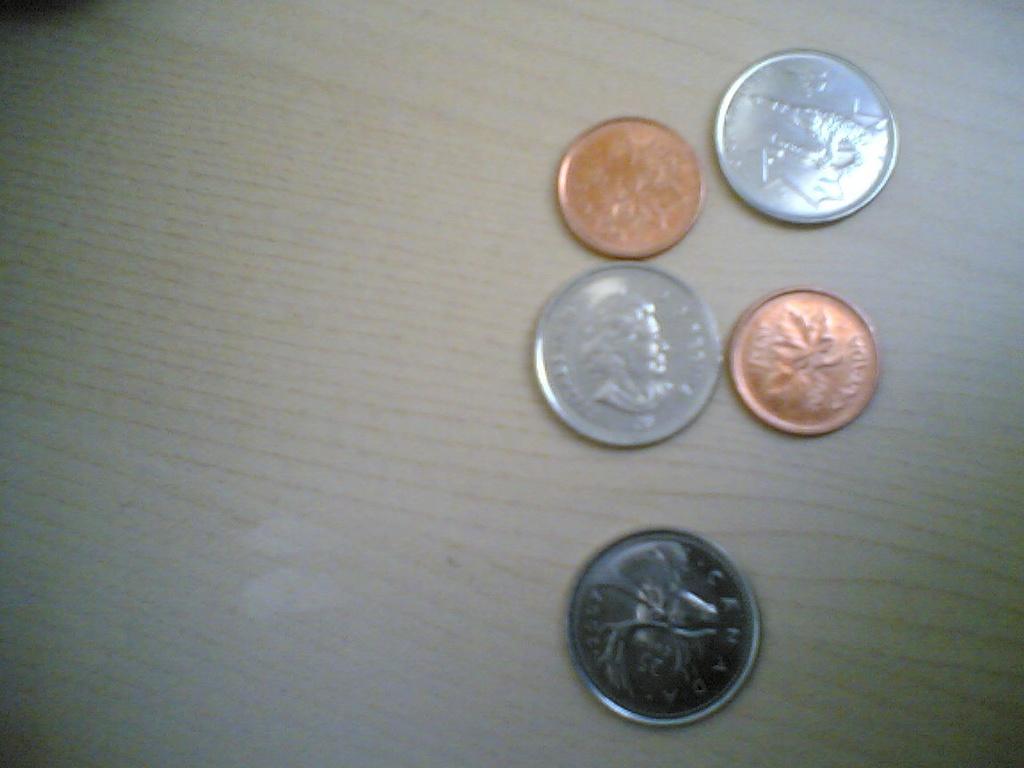What country is on the coin on the bottom?
Provide a short and direct response. Canada. 